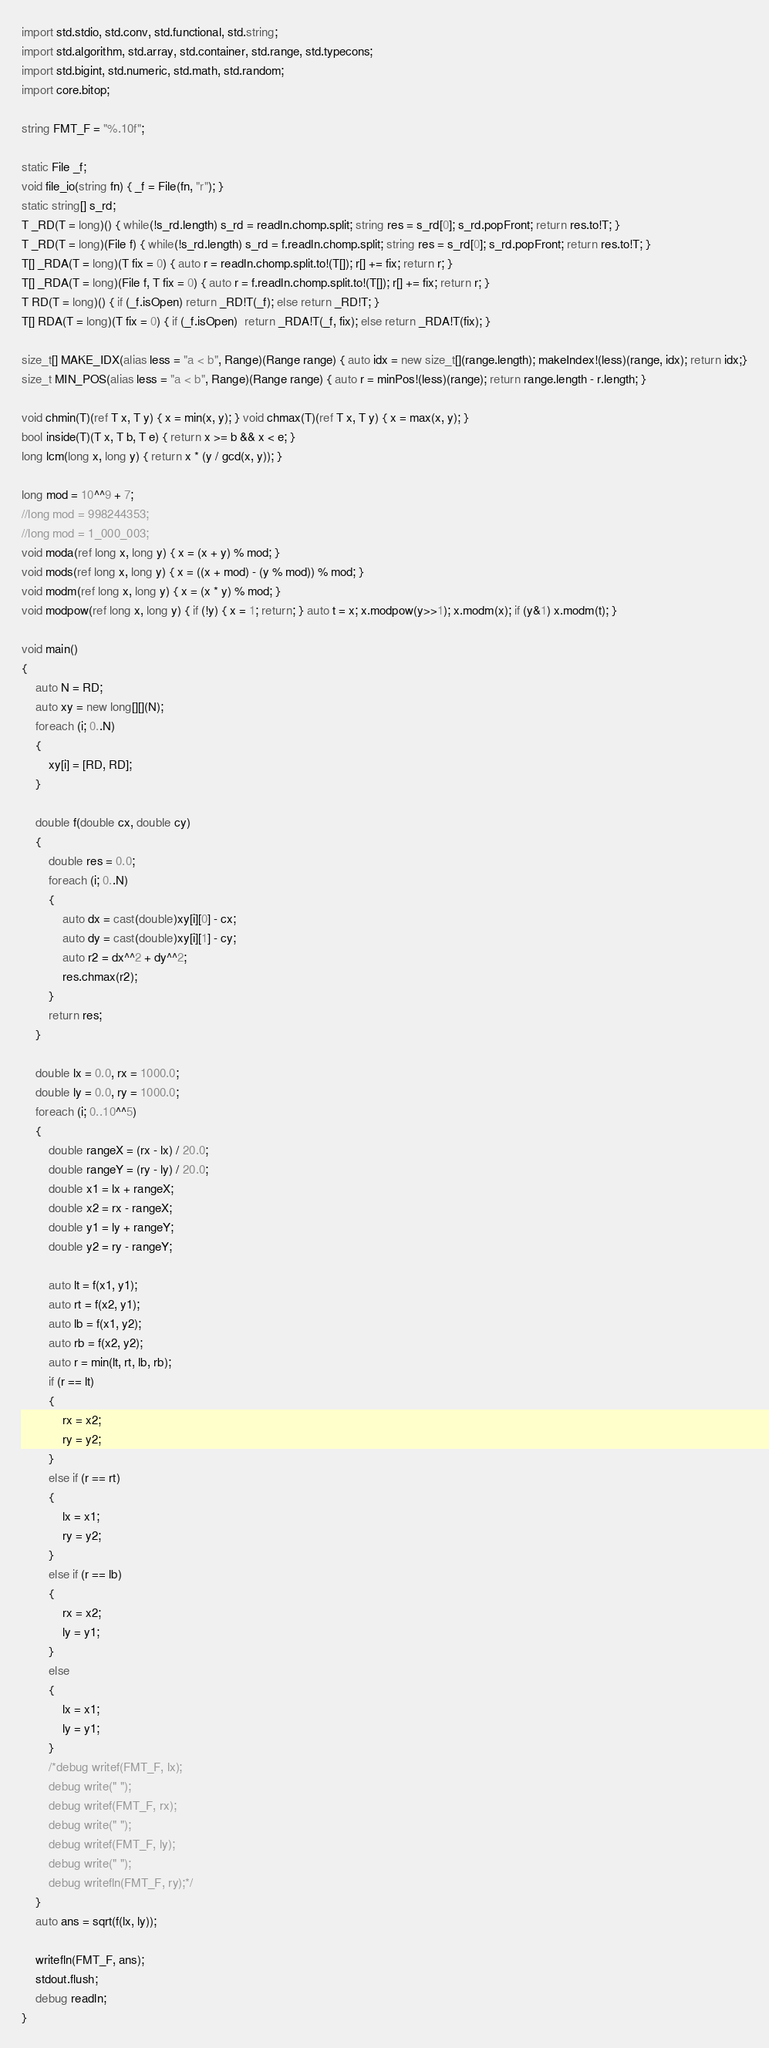Convert code to text. <code><loc_0><loc_0><loc_500><loc_500><_D_>import std.stdio, std.conv, std.functional, std.string;
import std.algorithm, std.array, std.container, std.range, std.typecons;
import std.bigint, std.numeric, std.math, std.random;
import core.bitop;

string FMT_F = "%.10f";

static File _f;
void file_io(string fn) { _f = File(fn, "r"); }
static string[] s_rd;
T _RD(T = long)() { while(!s_rd.length) s_rd = readln.chomp.split; string res = s_rd[0]; s_rd.popFront; return res.to!T; }
T _RD(T = long)(File f) { while(!s_rd.length) s_rd = f.readln.chomp.split; string res = s_rd[0]; s_rd.popFront; return res.to!T; }
T[] _RDA(T = long)(T fix = 0) { auto r = readln.chomp.split.to!(T[]); r[] += fix; return r; }
T[] _RDA(T = long)(File f, T fix = 0) { auto r = f.readln.chomp.split.to!(T[]); r[] += fix; return r; }
T RD(T = long)() { if (_f.isOpen) return _RD!T(_f); else return _RD!T; }
T[] RDA(T = long)(T fix = 0) { if (_f.isOpen)  return _RDA!T(_f, fix); else return _RDA!T(fix); }

size_t[] MAKE_IDX(alias less = "a < b", Range)(Range range) { auto idx = new size_t[](range.length); makeIndex!(less)(range, idx); return idx;}
size_t MIN_POS(alias less = "a < b", Range)(Range range) { auto r = minPos!(less)(range); return range.length - r.length; }

void chmin(T)(ref T x, T y) { x = min(x, y); } void chmax(T)(ref T x, T y) { x = max(x, y); }
bool inside(T)(T x, T b, T e) { return x >= b && x < e; }
long lcm(long x, long y) { return x * (y / gcd(x, y)); }

long mod = 10^^9 + 7;
//long mod = 998244353;
//long mod = 1_000_003;
void moda(ref long x, long y) { x = (x + y) % mod; }
void mods(ref long x, long y) { x = ((x + mod) - (y % mod)) % mod; }
void modm(ref long x, long y) { x = (x * y) % mod; }
void modpow(ref long x, long y) { if (!y) { x = 1; return; } auto t = x; x.modpow(y>>1); x.modm(x); if (y&1) x.modm(t); }

void main()
{
	auto N = RD;
	auto xy = new long[][](N);
	foreach (i; 0..N)
	{
		xy[i] = [RD, RD];
	}

	double f(double cx, double cy)
	{
		double res = 0.0;
		foreach (i; 0..N)
		{
			auto dx = cast(double)xy[i][0] - cx;
			auto dy = cast(double)xy[i][1] - cy;
			auto r2 = dx^^2 + dy^^2;
			res.chmax(r2);
		}
		return res;
	}

	double lx = 0.0, rx = 1000.0;
	double ly = 0.0, ry = 1000.0;
    foreach (i; 0..10^^5)
	{
		double rangeX = (rx - lx) / 20.0;
		double rangeY = (ry - ly) / 20.0;
        double x1 = lx + rangeX;
        double x2 = rx - rangeX;
		double y1 = ly + rangeY;
        double y2 = ry - rangeY;

		auto lt = f(x1, y1);
		auto rt = f(x2, y1);
		auto lb = f(x1, y2);
		auto rb = f(x2, y2);
		auto r = min(lt, rt, lb, rb);
        if (r == lt)
		{
			rx = x2;
			ry = y2;
		}
		else if (r == rt)
		{
			lx = x1;
			ry = y2;
		}
		else if (r == lb)
		{
			rx = x2;
			ly = y1;
		}
		else
		{
			lx = x1;
			ly = y1;
		}
		/*debug writef(FMT_F, lx);
		debug write(" ");
		debug writef(FMT_F, rx);
		debug write(" ");
		debug writef(FMT_F, ly);
		debug write(" ");
		debug writefln(FMT_F, ry);*/
    }
	auto ans = sqrt(f(lx, ly));

	writefln(FMT_F, ans);
	stdout.flush;
	debug readln;
}
</code> 